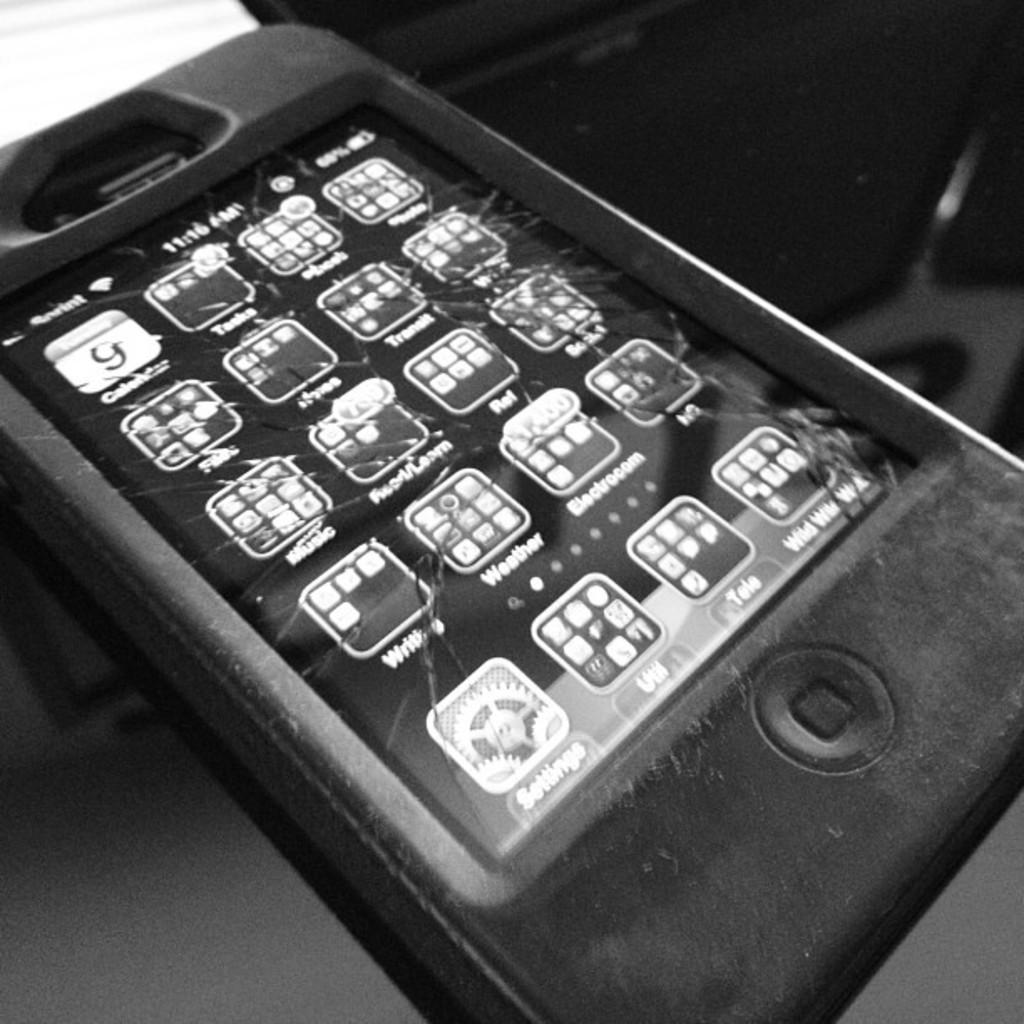<image>
Give a short and clear explanation of the subsequent image. A phone with Sprint service has a shattered touch screen. 